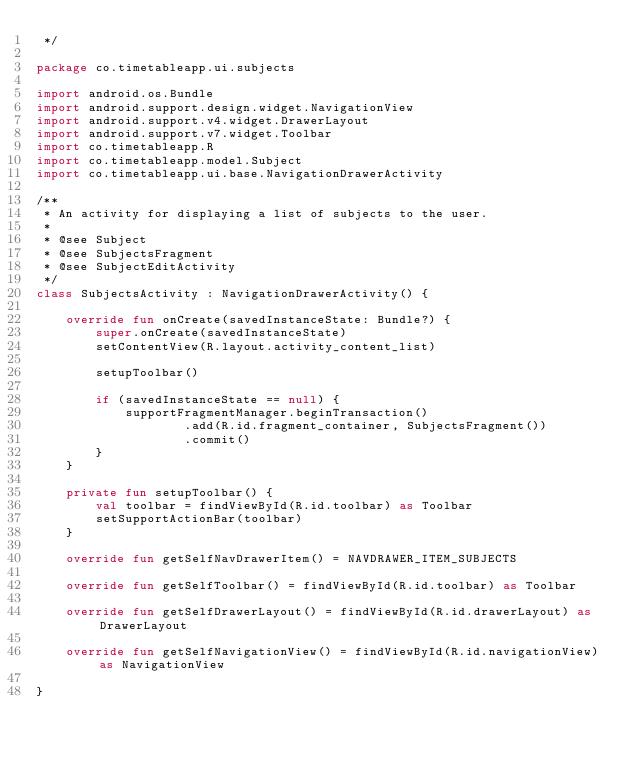Convert code to text. <code><loc_0><loc_0><loc_500><loc_500><_Kotlin_> */

package co.timetableapp.ui.subjects

import android.os.Bundle
import android.support.design.widget.NavigationView
import android.support.v4.widget.DrawerLayout
import android.support.v7.widget.Toolbar
import co.timetableapp.R
import co.timetableapp.model.Subject
import co.timetableapp.ui.base.NavigationDrawerActivity

/**
 * An activity for displaying a list of subjects to the user.
 *
 * @see Subject
 * @see SubjectsFragment
 * @see SubjectEditActivity
 */
class SubjectsActivity : NavigationDrawerActivity() {

    override fun onCreate(savedInstanceState: Bundle?) {
        super.onCreate(savedInstanceState)
        setContentView(R.layout.activity_content_list)

        setupToolbar()

        if (savedInstanceState == null) {
            supportFragmentManager.beginTransaction()
                    .add(R.id.fragment_container, SubjectsFragment())
                    .commit()
        }
    }

    private fun setupToolbar() {
        val toolbar = findViewById(R.id.toolbar) as Toolbar
        setSupportActionBar(toolbar)
    }

    override fun getSelfNavDrawerItem() = NAVDRAWER_ITEM_SUBJECTS

    override fun getSelfToolbar() = findViewById(R.id.toolbar) as Toolbar

    override fun getSelfDrawerLayout() = findViewById(R.id.drawerLayout) as DrawerLayout

    override fun getSelfNavigationView() = findViewById(R.id.navigationView) as NavigationView

}
</code> 